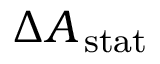<formula> <loc_0><loc_0><loc_500><loc_500>\Delta { { A _ { \, { s t a t } } } }</formula> 